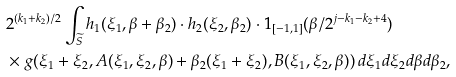<formula> <loc_0><loc_0><loc_500><loc_500>& 2 ^ { ( k _ { 1 } + k _ { 2 } ) / 2 } \int _ { \widetilde { S } } h _ { 1 } ( \xi _ { 1 } , \beta + \beta _ { 2 } ) \cdot h _ { 2 } ( \xi _ { 2 } , \beta _ { 2 } ) \cdot 1 _ { [ - 1 , 1 ] } ( \beta / 2 ^ { j - k _ { 1 } - k _ { 2 } + 4 } ) \\ & \times g ( \xi _ { 1 } + \xi _ { 2 } , A ( \xi _ { 1 } , \xi _ { 2 } , \beta ) + \beta _ { 2 } ( \xi _ { 1 } + \xi _ { 2 } ) , B ( \xi _ { 1 } , \xi _ { 2 } , \beta ) ) \, d \xi _ { 1 } d \xi _ { 2 } d \beta d \beta _ { 2 } ,</formula> 